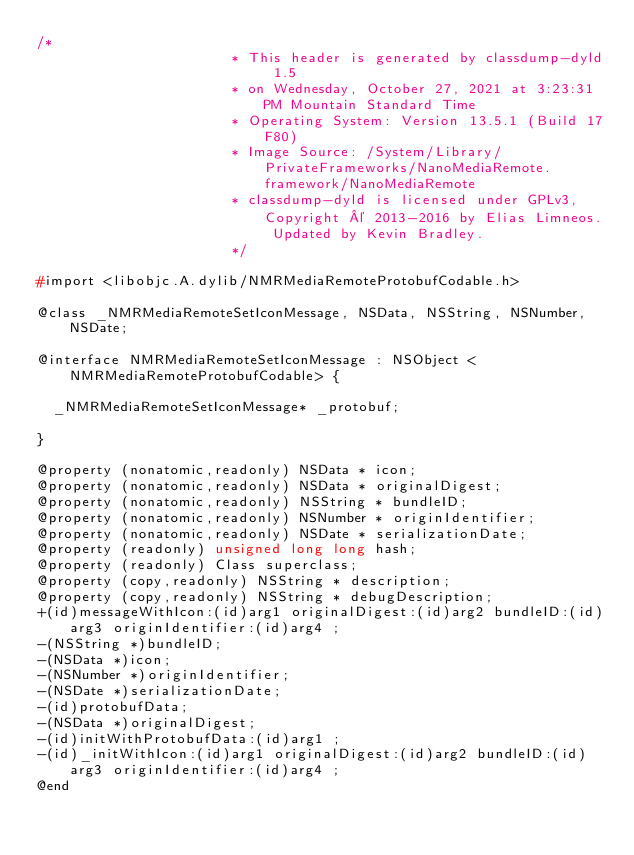<code> <loc_0><loc_0><loc_500><loc_500><_C_>/*
                       * This header is generated by classdump-dyld 1.5
                       * on Wednesday, October 27, 2021 at 3:23:31 PM Mountain Standard Time
                       * Operating System: Version 13.5.1 (Build 17F80)
                       * Image Source: /System/Library/PrivateFrameworks/NanoMediaRemote.framework/NanoMediaRemote
                       * classdump-dyld is licensed under GPLv3, Copyright © 2013-2016 by Elias Limneos. Updated by Kevin Bradley.
                       */

#import <libobjc.A.dylib/NMRMediaRemoteProtobufCodable.h>

@class _NMRMediaRemoteSetIconMessage, NSData, NSString, NSNumber, NSDate;

@interface NMRMediaRemoteSetIconMessage : NSObject <NMRMediaRemoteProtobufCodable> {

	_NMRMediaRemoteSetIconMessage* _protobuf;

}

@property (nonatomic,readonly) NSData * icon; 
@property (nonatomic,readonly) NSData * originalDigest; 
@property (nonatomic,readonly) NSString * bundleID; 
@property (nonatomic,readonly) NSNumber * originIdentifier; 
@property (nonatomic,readonly) NSDate * serializationDate; 
@property (readonly) unsigned long long hash; 
@property (readonly) Class superclass; 
@property (copy,readonly) NSString * description; 
@property (copy,readonly) NSString * debugDescription; 
+(id)messageWithIcon:(id)arg1 originalDigest:(id)arg2 bundleID:(id)arg3 originIdentifier:(id)arg4 ;
-(NSString *)bundleID;
-(NSData *)icon;
-(NSNumber *)originIdentifier;
-(NSDate *)serializationDate;
-(id)protobufData;
-(NSData *)originalDigest;
-(id)initWithProtobufData:(id)arg1 ;
-(id)_initWithIcon:(id)arg1 originalDigest:(id)arg2 bundleID:(id)arg3 originIdentifier:(id)arg4 ;
@end

</code> 